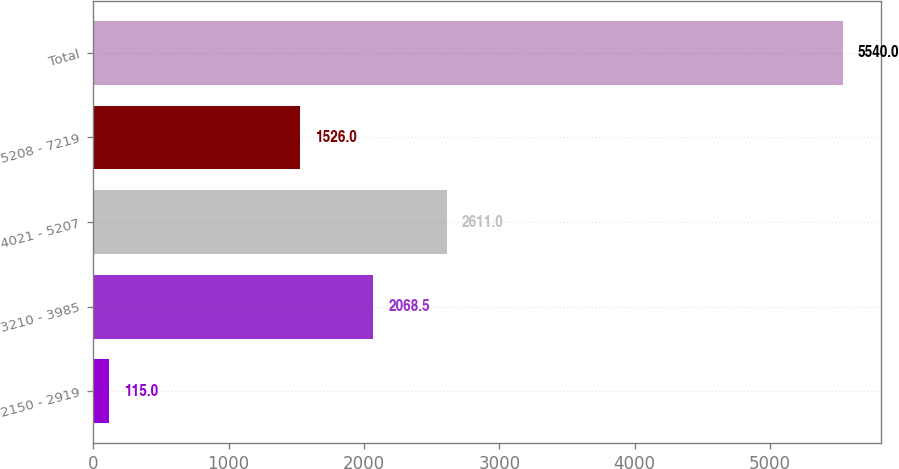<chart> <loc_0><loc_0><loc_500><loc_500><bar_chart><fcel>2150 - 2919<fcel>3210 - 3985<fcel>4021 - 5207<fcel>5208 - 7219<fcel>Total<nl><fcel>115<fcel>2068.5<fcel>2611<fcel>1526<fcel>5540<nl></chart> 